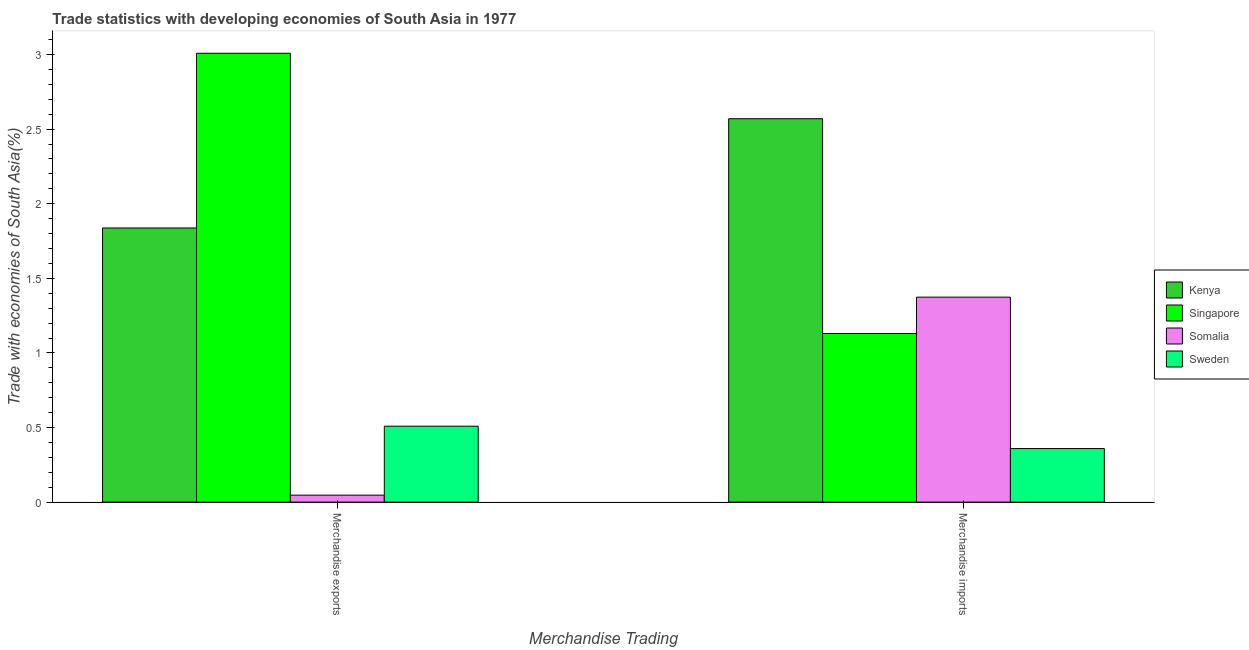How many groups of bars are there?
Provide a short and direct response. 2. What is the label of the 2nd group of bars from the left?
Provide a short and direct response. Merchandise imports. What is the merchandise imports in Sweden?
Give a very brief answer. 0.36. Across all countries, what is the maximum merchandise imports?
Provide a succinct answer. 2.57. Across all countries, what is the minimum merchandise exports?
Give a very brief answer. 0.05. In which country was the merchandise imports maximum?
Offer a terse response. Kenya. In which country was the merchandise exports minimum?
Ensure brevity in your answer.  Somalia. What is the total merchandise imports in the graph?
Provide a succinct answer. 5.43. What is the difference between the merchandise imports in Singapore and that in Sweden?
Your answer should be compact. 0.77. What is the difference between the merchandise imports in Singapore and the merchandise exports in Sweden?
Your answer should be very brief. 0.62. What is the average merchandise imports per country?
Offer a very short reply. 1.36. What is the difference between the merchandise imports and merchandise exports in Sweden?
Your response must be concise. -0.15. What is the ratio of the merchandise imports in Singapore to that in Kenya?
Your answer should be compact. 0.44. In how many countries, is the merchandise imports greater than the average merchandise imports taken over all countries?
Make the answer very short. 2. What does the 1st bar from the left in Merchandise imports represents?
Offer a very short reply. Kenya. How many bars are there?
Provide a succinct answer. 8. Are all the bars in the graph horizontal?
Make the answer very short. No. How many countries are there in the graph?
Offer a terse response. 4. Are the values on the major ticks of Y-axis written in scientific E-notation?
Make the answer very short. No. Where does the legend appear in the graph?
Your response must be concise. Center right. How many legend labels are there?
Provide a short and direct response. 4. What is the title of the graph?
Ensure brevity in your answer.  Trade statistics with developing economies of South Asia in 1977. What is the label or title of the X-axis?
Give a very brief answer. Merchandise Trading. What is the label or title of the Y-axis?
Your answer should be very brief. Trade with economies of South Asia(%). What is the Trade with economies of South Asia(%) in Kenya in Merchandise exports?
Keep it short and to the point. 1.84. What is the Trade with economies of South Asia(%) of Singapore in Merchandise exports?
Offer a terse response. 3.01. What is the Trade with economies of South Asia(%) in Somalia in Merchandise exports?
Your answer should be compact. 0.05. What is the Trade with economies of South Asia(%) in Sweden in Merchandise exports?
Offer a terse response. 0.51. What is the Trade with economies of South Asia(%) in Kenya in Merchandise imports?
Ensure brevity in your answer.  2.57. What is the Trade with economies of South Asia(%) of Singapore in Merchandise imports?
Give a very brief answer. 1.13. What is the Trade with economies of South Asia(%) of Somalia in Merchandise imports?
Your response must be concise. 1.37. What is the Trade with economies of South Asia(%) in Sweden in Merchandise imports?
Your response must be concise. 0.36. Across all Merchandise Trading, what is the maximum Trade with economies of South Asia(%) of Kenya?
Provide a succinct answer. 2.57. Across all Merchandise Trading, what is the maximum Trade with economies of South Asia(%) in Singapore?
Your answer should be very brief. 3.01. Across all Merchandise Trading, what is the maximum Trade with economies of South Asia(%) of Somalia?
Your answer should be very brief. 1.37. Across all Merchandise Trading, what is the maximum Trade with economies of South Asia(%) in Sweden?
Ensure brevity in your answer.  0.51. Across all Merchandise Trading, what is the minimum Trade with economies of South Asia(%) of Kenya?
Offer a terse response. 1.84. Across all Merchandise Trading, what is the minimum Trade with economies of South Asia(%) in Singapore?
Make the answer very short. 1.13. Across all Merchandise Trading, what is the minimum Trade with economies of South Asia(%) of Somalia?
Make the answer very short. 0.05. Across all Merchandise Trading, what is the minimum Trade with economies of South Asia(%) of Sweden?
Provide a short and direct response. 0.36. What is the total Trade with economies of South Asia(%) in Kenya in the graph?
Give a very brief answer. 4.41. What is the total Trade with economies of South Asia(%) of Singapore in the graph?
Make the answer very short. 4.14. What is the total Trade with economies of South Asia(%) of Somalia in the graph?
Offer a very short reply. 1.42. What is the total Trade with economies of South Asia(%) of Sweden in the graph?
Keep it short and to the point. 0.87. What is the difference between the Trade with economies of South Asia(%) of Kenya in Merchandise exports and that in Merchandise imports?
Provide a short and direct response. -0.73. What is the difference between the Trade with economies of South Asia(%) in Singapore in Merchandise exports and that in Merchandise imports?
Your response must be concise. 1.88. What is the difference between the Trade with economies of South Asia(%) of Somalia in Merchandise exports and that in Merchandise imports?
Ensure brevity in your answer.  -1.33. What is the difference between the Trade with economies of South Asia(%) of Sweden in Merchandise exports and that in Merchandise imports?
Make the answer very short. 0.15. What is the difference between the Trade with economies of South Asia(%) in Kenya in Merchandise exports and the Trade with economies of South Asia(%) in Singapore in Merchandise imports?
Keep it short and to the point. 0.71. What is the difference between the Trade with economies of South Asia(%) in Kenya in Merchandise exports and the Trade with economies of South Asia(%) in Somalia in Merchandise imports?
Keep it short and to the point. 0.46. What is the difference between the Trade with economies of South Asia(%) in Kenya in Merchandise exports and the Trade with economies of South Asia(%) in Sweden in Merchandise imports?
Provide a short and direct response. 1.48. What is the difference between the Trade with economies of South Asia(%) in Singapore in Merchandise exports and the Trade with economies of South Asia(%) in Somalia in Merchandise imports?
Your answer should be very brief. 1.63. What is the difference between the Trade with economies of South Asia(%) in Singapore in Merchandise exports and the Trade with economies of South Asia(%) in Sweden in Merchandise imports?
Make the answer very short. 2.65. What is the difference between the Trade with economies of South Asia(%) of Somalia in Merchandise exports and the Trade with economies of South Asia(%) of Sweden in Merchandise imports?
Ensure brevity in your answer.  -0.31. What is the average Trade with economies of South Asia(%) of Kenya per Merchandise Trading?
Offer a very short reply. 2.2. What is the average Trade with economies of South Asia(%) of Singapore per Merchandise Trading?
Provide a succinct answer. 2.07. What is the average Trade with economies of South Asia(%) of Somalia per Merchandise Trading?
Your answer should be very brief. 0.71. What is the average Trade with economies of South Asia(%) in Sweden per Merchandise Trading?
Ensure brevity in your answer.  0.43. What is the difference between the Trade with economies of South Asia(%) in Kenya and Trade with economies of South Asia(%) in Singapore in Merchandise exports?
Your answer should be compact. -1.17. What is the difference between the Trade with economies of South Asia(%) in Kenya and Trade with economies of South Asia(%) in Somalia in Merchandise exports?
Keep it short and to the point. 1.79. What is the difference between the Trade with economies of South Asia(%) in Kenya and Trade with economies of South Asia(%) in Sweden in Merchandise exports?
Keep it short and to the point. 1.33. What is the difference between the Trade with economies of South Asia(%) in Singapore and Trade with economies of South Asia(%) in Somalia in Merchandise exports?
Make the answer very short. 2.96. What is the difference between the Trade with economies of South Asia(%) of Singapore and Trade with economies of South Asia(%) of Sweden in Merchandise exports?
Offer a very short reply. 2.5. What is the difference between the Trade with economies of South Asia(%) of Somalia and Trade with economies of South Asia(%) of Sweden in Merchandise exports?
Your response must be concise. -0.46. What is the difference between the Trade with economies of South Asia(%) in Kenya and Trade with economies of South Asia(%) in Singapore in Merchandise imports?
Offer a terse response. 1.44. What is the difference between the Trade with economies of South Asia(%) in Kenya and Trade with economies of South Asia(%) in Somalia in Merchandise imports?
Keep it short and to the point. 1.2. What is the difference between the Trade with economies of South Asia(%) of Kenya and Trade with economies of South Asia(%) of Sweden in Merchandise imports?
Your answer should be compact. 2.21. What is the difference between the Trade with economies of South Asia(%) of Singapore and Trade with economies of South Asia(%) of Somalia in Merchandise imports?
Ensure brevity in your answer.  -0.24. What is the difference between the Trade with economies of South Asia(%) in Singapore and Trade with economies of South Asia(%) in Sweden in Merchandise imports?
Your answer should be very brief. 0.77. What is the difference between the Trade with economies of South Asia(%) of Somalia and Trade with economies of South Asia(%) of Sweden in Merchandise imports?
Your answer should be compact. 1.01. What is the ratio of the Trade with economies of South Asia(%) of Kenya in Merchandise exports to that in Merchandise imports?
Offer a very short reply. 0.71. What is the ratio of the Trade with economies of South Asia(%) of Singapore in Merchandise exports to that in Merchandise imports?
Ensure brevity in your answer.  2.66. What is the ratio of the Trade with economies of South Asia(%) of Somalia in Merchandise exports to that in Merchandise imports?
Give a very brief answer. 0.03. What is the ratio of the Trade with economies of South Asia(%) in Sweden in Merchandise exports to that in Merchandise imports?
Your response must be concise. 1.42. What is the difference between the highest and the second highest Trade with economies of South Asia(%) in Kenya?
Make the answer very short. 0.73. What is the difference between the highest and the second highest Trade with economies of South Asia(%) in Singapore?
Provide a succinct answer. 1.88. What is the difference between the highest and the second highest Trade with economies of South Asia(%) in Somalia?
Offer a very short reply. 1.33. What is the difference between the highest and the second highest Trade with economies of South Asia(%) of Sweden?
Offer a terse response. 0.15. What is the difference between the highest and the lowest Trade with economies of South Asia(%) of Kenya?
Offer a terse response. 0.73. What is the difference between the highest and the lowest Trade with economies of South Asia(%) of Singapore?
Your answer should be compact. 1.88. What is the difference between the highest and the lowest Trade with economies of South Asia(%) in Somalia?
Provide a short and direct response. 1.33. What is the difference between the highest and the lowest Trade with economies of South Asia(%) in Sweden?
Ensure brevity in your answer.  0.15. 